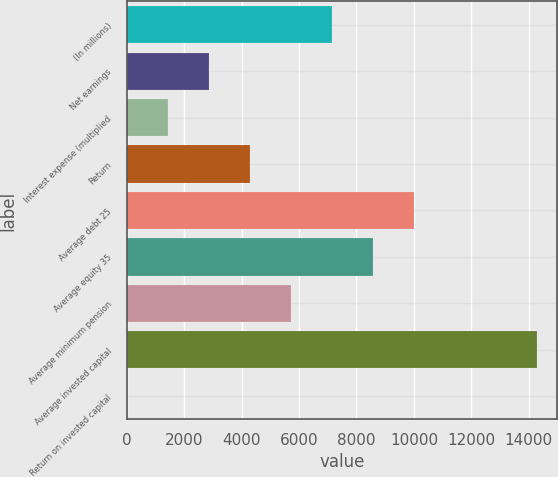<chart> <loc_0><loc_0><loc_500><loc_500><bar_chart><fcel>(In millions)<fcel>Net earnings<fcel>Interest expense (multiplied<fcel>Return<fcel>Average debt 25<fcel>Average equity 35<fcel>Average minimum pension<fcel>Average invested capital<fcel>Return on invested capital<nl><fcel>7147.8<fcel>2864.88<fcel>1437.24<fcel>4292.52<fcel>10003.1<fcel>8575.44<fcel>5720.16<fcel>14286<fcel>9.6<nl></chart> 